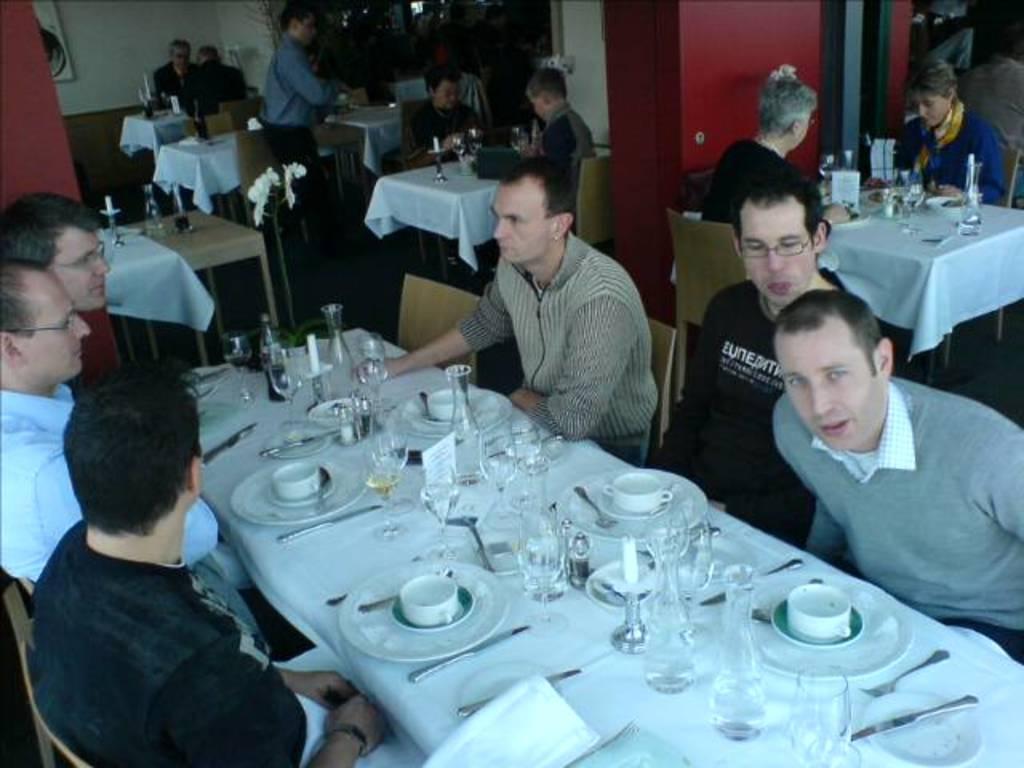Can you describe this image briefly? This is a picture taken in a restaurant, there are a group of people sitting on a chair in front of these people there is a table covered with white cloth on top of the table there are knife, plate, saucer, cup, glasses and a fork. Background of this people is a wall. 